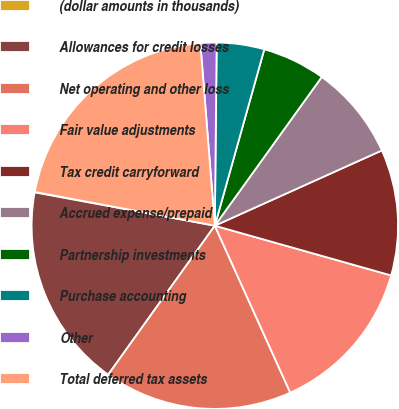Convert chart. <chart><loc_0><loc_0><loc_500><loc_500><pie_chart><fcel>(dollar amounts in thousands)<fcel>Allowances for credit losses<fcel>Net operating and other loss<fcel>Fair value adjustments<fcel>Tax credit carryforward<fcel>Accrued expense/prepaid<fcel>Partnership investments<fcel>Purchase accounting<fcel>Other<fcel>Total deferred tax assets<nl><fcel>0.04%<fcel>18.02%<fcel>16.64%<fcel>13.87%<fcel>11.11%<fcel>8.34%<fcel>5.57%<fcel>4.19%<fcel>1.42%<fcel>20.79%<nl></chart> 